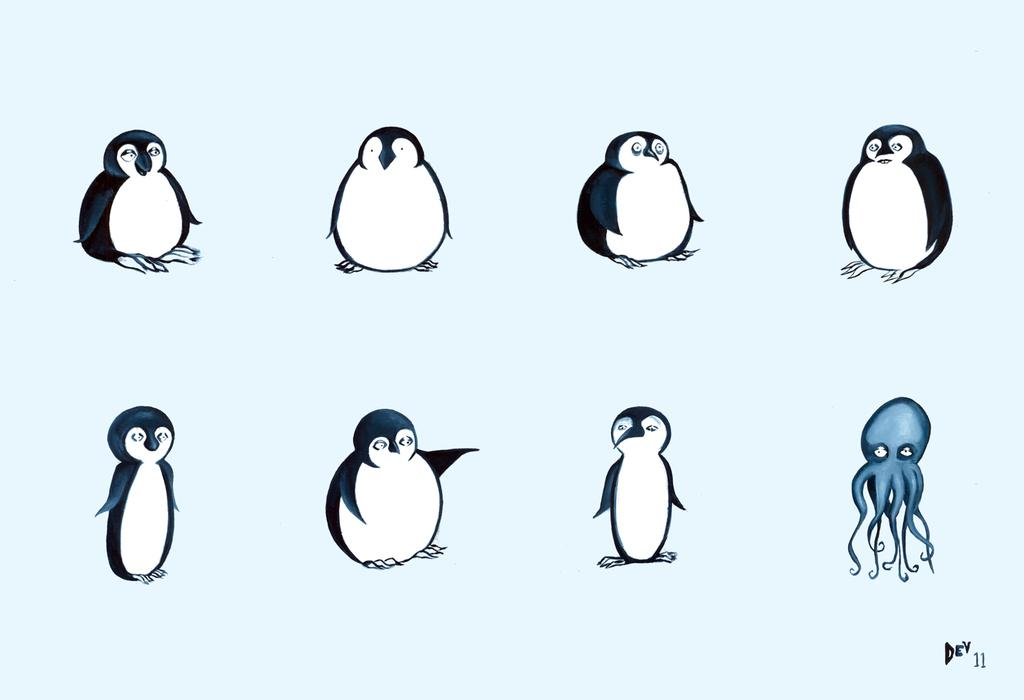What is featured on the poster in the image? The poster contains images of penguins and an octopus. Can you describe the content of the poster in more detail? The poster features images of penguins and an octopus, which are both marine animals. What sense is being used by the geese in the image? There are no geese present in the image, so it is not possible to determine which sense they might be using. 